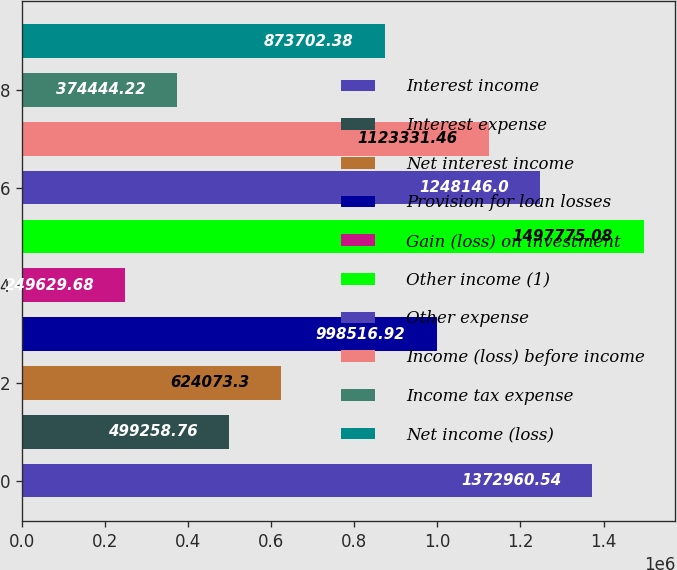Convert chart to OTSL. <chart><loc_0><loc_0><loc_500><loc_500><bar_chart><fcel>Interest income<fcel>Interest expense<fcel>Net interest income<fcel>Provision for loan losses<fcel>Gain (loss) on investment<fcel>Other income (1)<fcel>Other expense<fcel>Income (loss) before income<fcel>Income tax expense<fcel>Net income (loss)<nl><fcel>1.37296e+06<fcel>499259<fcel>624073<fcel>998517<fcel>249630<fcel>1.49778e+06<fcel>1.24815e+06<fcel>1.12333e+06<fcel>374444<fcel>873702<nl></chart> 